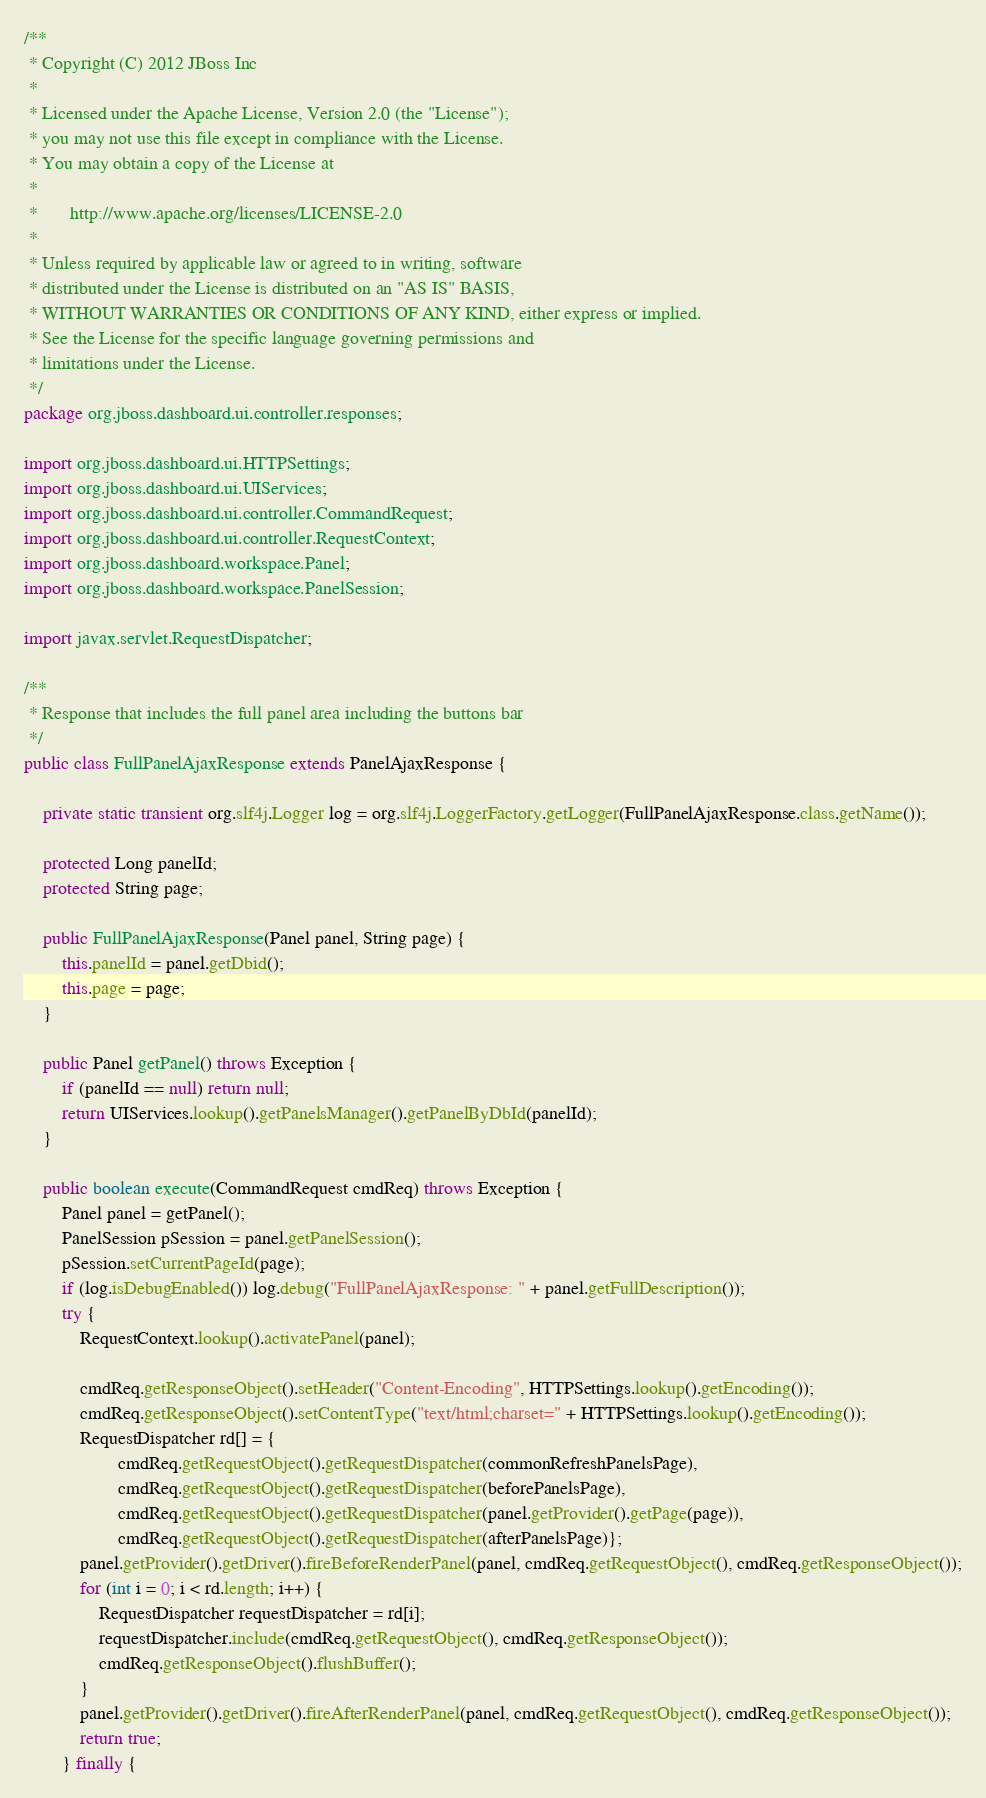Convert code to text. <code><loc_0><loc_0><loc_500><loc_500><_Java_>/**
 * Copyright (C) 2012 JBoss Inc
 *
 * Licensed under the Apache License, Version 2.0 (the "License");
 * you may not use this file except in compliance with the License.
 * You may obtain a copy of the License at
 *
 *       http://www.apache.org/licenses/LICENSE-2.0
 *
 * Unless required by applicable law or agreed to in writing, software
 * distributed under the License is distributed on an "AS IS" BASIS,
 * WITHOUT WARRANTIES OR CONDITIONS OF ANY KIND, either express or implied.
 * See the License for the specific language governing permissions and
 * limitations under the License.
 */
package org.jboss.dashboard.ui.controller.responses;

import org.jboss.dashboard.ui.HTTPSettings;
import org.jboss.dashboard.ui.UIServices;
import org.jboss.dashboard.ui.controller.CommandRequest;
import org.jboss.dashboard.ui.controller.RequestContext;
import org.jboss.dashboard.workspace.Panel;
import org.jboss.dashboard.workspace.PanelSession;

import javax.servlet.RequestDispatcher;

/**
 * Response that includes the full panel area including the buttons bar
 */
public class FullPanelAjaxResponse extends PanelAjaxResponse {

    private static transient org.slf4j.Logger log = org.slf4j.LoggerFactory.getLogger(FullPanelAjaxResponse.class.getName());

    protected Long panelId;
    protected String page;

    public FullPanelAjaxResponse(Panel panel, String page) {
        this.panelId = panel.getDbid();
        this.page = page;
    }

    public Panel getPanel() throws Exception {
        if (panelId == null) return null;
        return UIServices.lookup().getPanelsManager().getPanelByDbId(panelId);
    }

    public boolean execute(CommandRequest cmdReq) throws Exception {
        Panel panel = getPanel();
        PanelSession pSession = panel.getPanelSession();
        pSession.setCurrentPageId(page);
        if (log.isDebugEnabled()) log.debug("FullPanelAjaxResponse: " + panel.getFullDescription());
        try {
            RequestContext.lookup().activatePanel(panel);

            cmdReq.getResponseObject().setHeader("Content-Encoding", HTTPSettings.lookup().getEncoding());
            cmdReq.getResponseObject().setContentType("text/html;charset=" + HTTPSettings.lookup().getEncoding());
            RequestDispatcher rd[] = {
                    cmdReq.getRequestObject().getRequestDispatcher(commonRefreshPanelsPage),
                    cmdReq.getRequestObject().getRequestDispatcher(beforePanelsPage),
                    cmdReq.getRequestObject().getRequestDispatcher(panel.getProvider().getPage(page)),
                    cmdReq.getRequestObject().getRequestDispatcher(afterPanelsPage)};
            panel.getProvider().getDriver().fireBeforeRenderPanel(panel, cmdReq.getRequestObject(), cmdReq.getResponseObject());
            for (int i = 0; i < rd.length; i++) {
                RequestDispatcher requestDispatcher = rd[i];
                requestDispatcher.include(cmdReq.getRequestObject(), cmdReq.getResponseObject());
                cmdReq.getResponseObject().flushBuffer();
            }
            panel.getProvider().getDriver().fireAfterRenderPanel(panel, cmdReq.getRequestObject(), cmdReq.getResponseObject());
            return true;
        } finally {</code> 